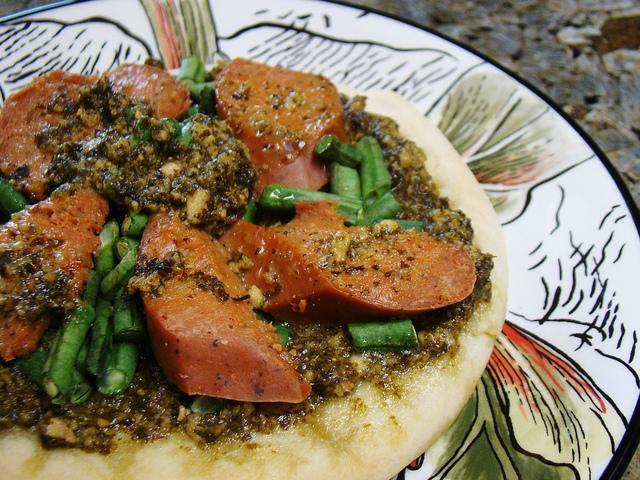How many red umbrellas are to the right of the woman in the middle?
Give a very brief answer. 0. 